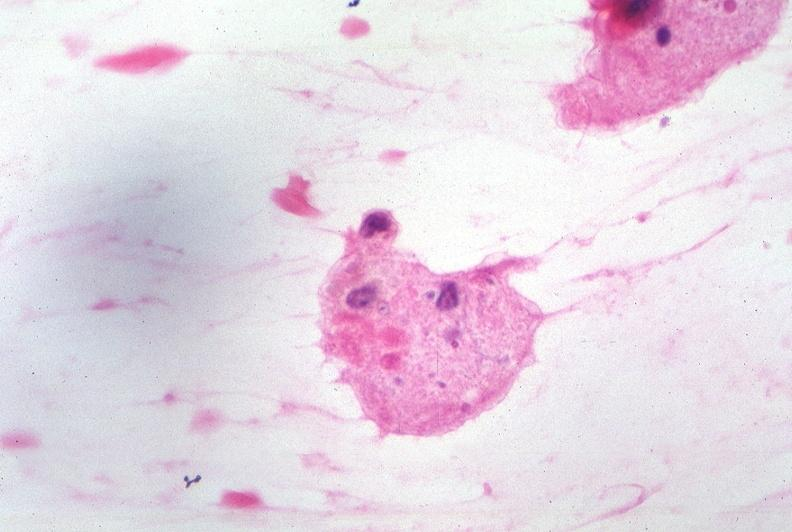s metastatic carcinoma breast present?
Answer the question using a single word or phrase. No 